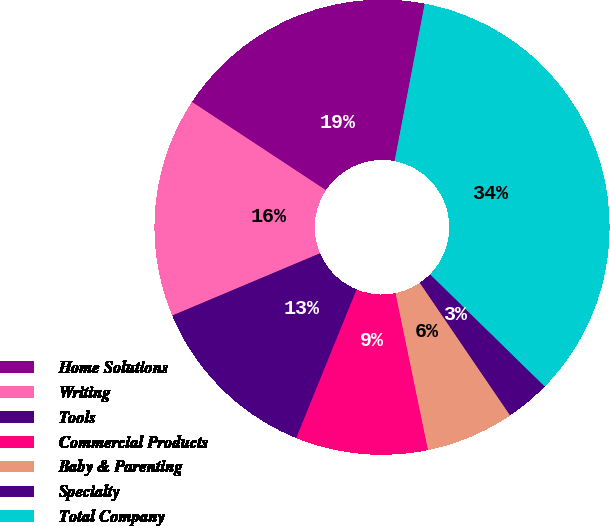Convert chart. <chart><loc_0><loc_0><loc_500><loc_500><pie_chart><fcel>Home Solutions<fcel>Writing<fcel>Tools<fcel>Commercial Products<fcel>Baby & Parenting<fcel>Specialty<fcel>Total Company<nl><fcel>18.74%<fcel>15.62%<fcel>12.51%<fcel>9.39%<fcel>6.27%<fcel>3.16%<fcel>34.32%<nl></chart> 